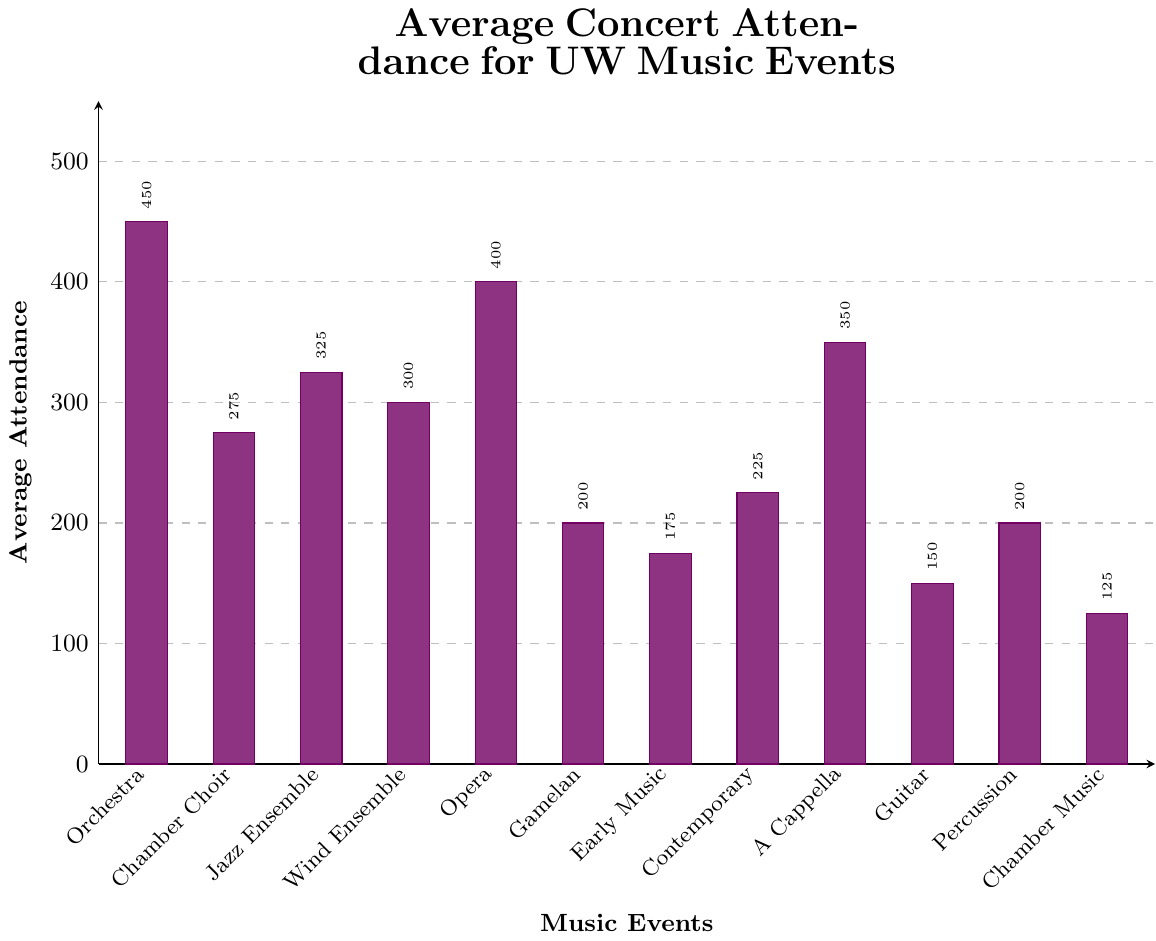What's the highest average concert attendance for any UW Music event? Look at each bar's height on the bar chart. The 'UW Symphony Orchestra' has the tallest bar, representing the highest average concert attendance of 450 attendees.
Answer: 450 Which event has a higher average attendance: the UW Chamber Choir or the UW A Cappella Groups? Compare the heights of the bars labeled 'Chamber Choir' and 'A Cappella Groups.' The 'A Cappella Groups' bar is taller with an average attendance of 350 compared to the 'Chamber Choir' with 275.
Answer: A Cappella Groups What is the average attendance difference between the UW Symphony Orchestra and the UW Opera? Find the heights of the bars for 'Orchestra' (450) and 'Opera' (400). Calculate the difference: 450 - 400 = 50.
Answer: 50 Which event has the lowest average attendance? Identify the shortest bar in the chart, which corresponds to the 'Chamber Music Groups' with an average attendance of 125.
Answer: Chamber Music Groups What's the average attendance for events with an average attendance greater than 300? Identify events with attendance greater than 300: UW Symphony Orchestra (450), UW Opera (400), UW A Cappella Groups (350), and UW Jazz Ensemble (325). Calculate their average: (450 + 400 + 350 + 325) / 4 = 1525 / 4 = 381.25.
Answer: 381.25 Calculate the total average attendance for all the events combined. Sum the average attendances of all events: 450 + 275 + 325 + 300 + 400 + 200 + 175 + 225 + 350 + 150 + 200 + 125. The total is 3,175.
Answer: 3,175 Is the average attendance of the UW Wind Ensemble more than twice the average attendance of the UW Guitar Ensemble? UW Wind Ensemble has 300 and UW Guitar Ensemble has 150. Twice the Guitar Ensemble is 150 * 2 = 300. Since 300 is equal to twice 150, the answer is no.
Answer: No What is the average attendance of the UW Percussion Ensemble compared to the UW Balinese Gamelan? Compare the heights of the bars for 'Percussion' and 'Gamelan.' Both have the same height, representing an average attendance of 200.
Answer: Equal 